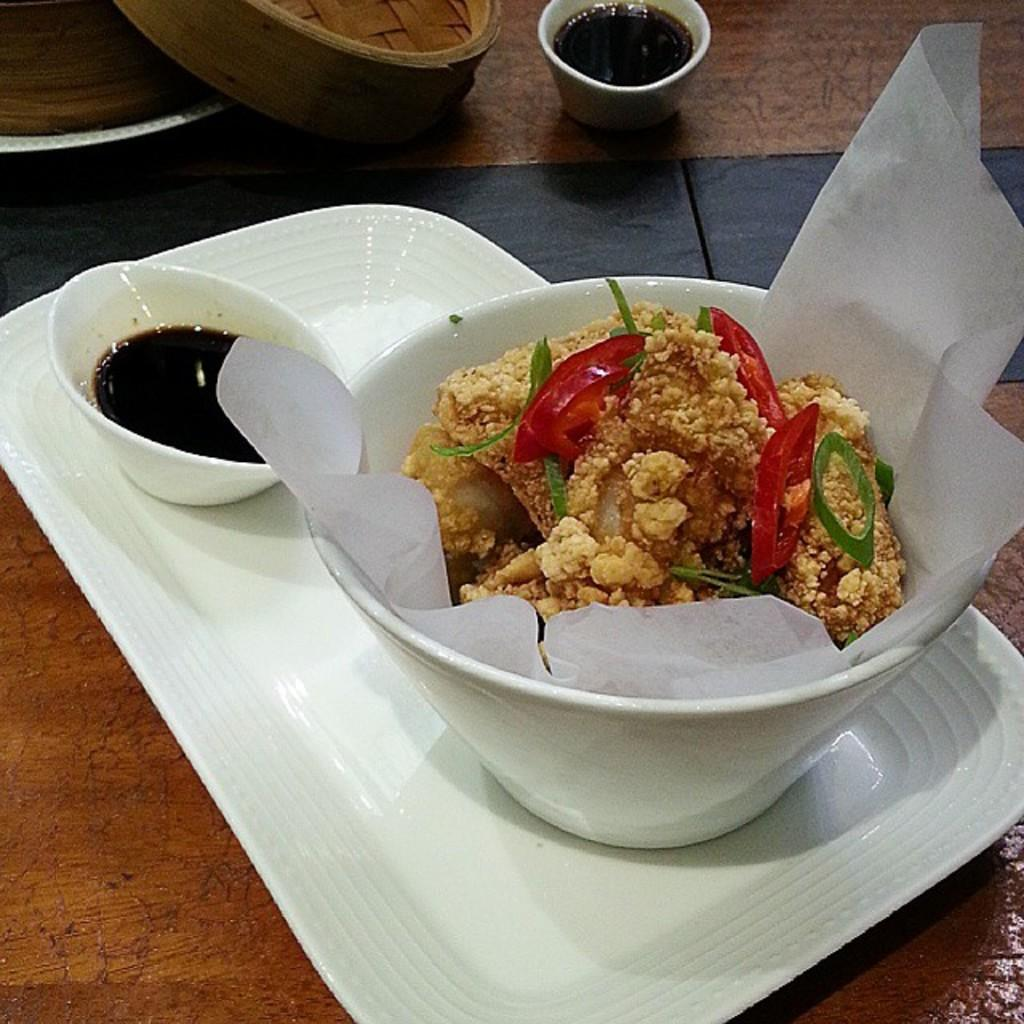What is the main piece of furniture in the image? There is a table in the image. What is placed on the table? There is a food item placed in a bowl on the table. What accompanies the food item in the bowl? There is sauce in the image. What other objects can be seen on the table? There are other objects on the table. Where is the bomb located in the image? There is no bomb present in the image. What type of railway can be seen in the image? There is no railway present in the image. 